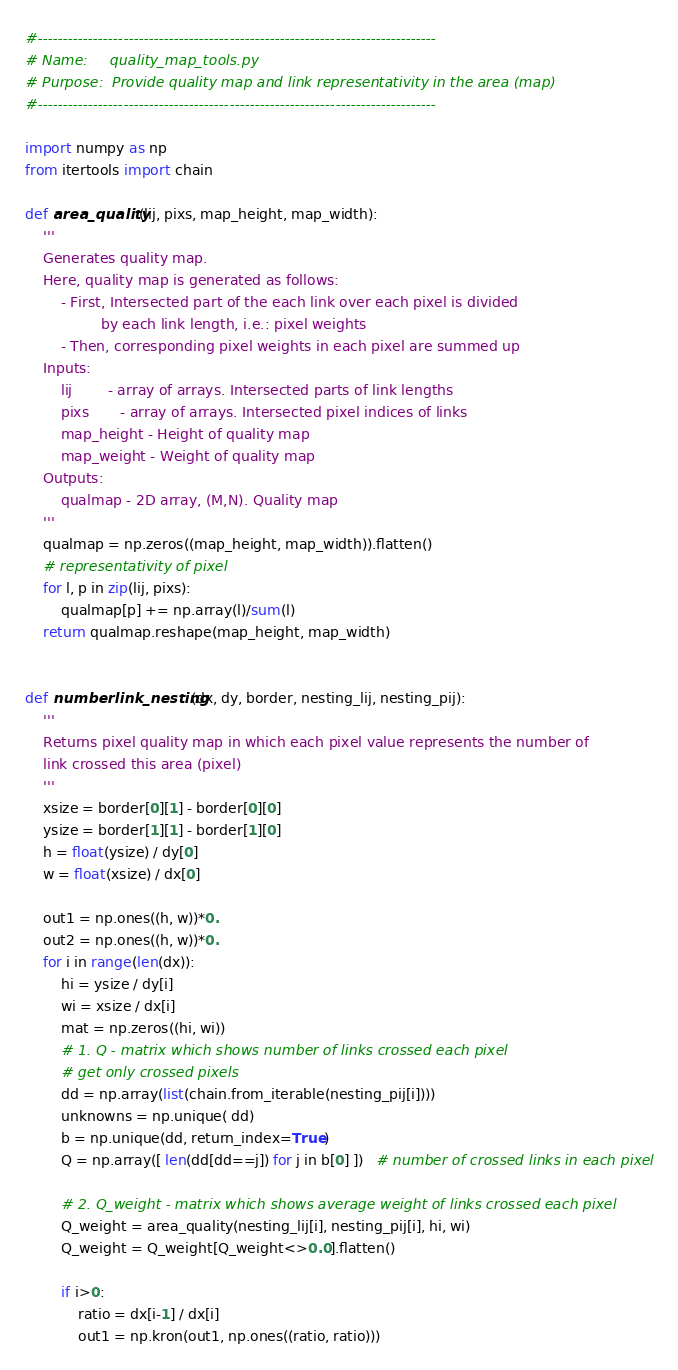<code> <loc_0><loc_0><loc_500><loc_500><_Python_>#-------------------------------------------------------------------------------
# Name:     quality_map_tools.py
# Purpose:  Provide quality map and link representativity in the area (map)
#-------------------------------------------------------------------------------

import numpy as np
from itertools import chain

def area_quality(lij, pixs, map_height, map_width):
    '''
    Generates quality map.
    Here, quality map is generated as follows:
        - First, Intersected part of the each link over each pixel is divided
                 by each link length, i.e.: pixel weights
        - Then, corresponding pixel weights in each pixel are summed up
    Inputs:
        lij        - array of arrays. Intersected parts of link lengths
        pixs       - array of arrays. Intersected pixel indices of links
        map_height - Height of quality map
        map_weight - Weight of quality map
    Outputs:
        qualmap - 2D array, (M,N). Quality map
    '''
    qualmap = np.zeros((map_height, map_width)).flatten()
    # representativity of pixel
    for l, p in zip(lij, pixs):
        qualmap[p] += np.array(l)/sum(l)
    return qualmap.reshape(map_height, map_width)


def numberlink_nesting(dx, dy, border, nesting_lij, nesting_pij):
    '''
    Returns pixel quality map in which each pixel value represents the number of
    link crossed this area (pixel)
    '''
    xsize = border[0][1] - border[0][0]
    ysize = border[1][1] - border[1][0]
    h = float(ysize) / dy[0]
    w = float(xsize) / dx[0]

    out1 = np.ones((h, w))*0.
    out2 = np.ones((h, w))*0.
    for i in range(len(dx)):
        hi = ysize / dy[i]
        wi = xsize / dx[i]
        mat = np.zeros((hi, wi))
        # 1. Q - matrix which shows number of links crossed each pixel
        # get only crossed pixels
        dd = np.array(list(chain.from_iterable(nesting_pij[i])))
        unknowns = np.unique( dd)
        b = np.unique(dd, return_index=True)
        Q = np.array([ len(dd[dd==j]) for j in b[0] ])   # number of crossed links in each pixel

        # 2. Q_weight - matrix which shows average weight of links crossed each pixel
        Q_weight = area_quality(nesting_lij[i], nesting_pij[i], hi, wi)
        Q_weight = Q_weight[Q_weight<>0.0].flatten()

        if i>0:
            ratio = dx[i-1] / dx[i]
            out1 = np.kron(out1, np.ones((ratio, ratio)))</code> 